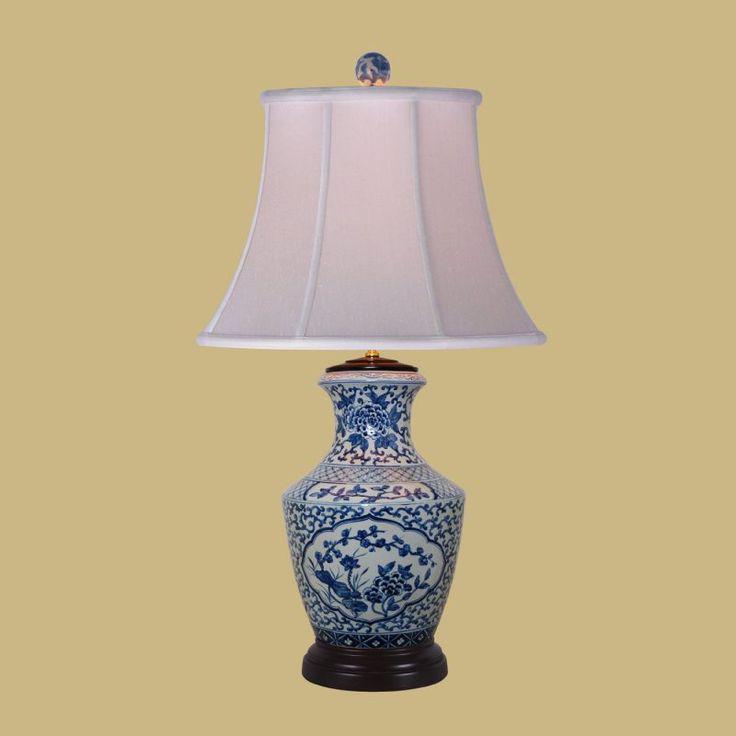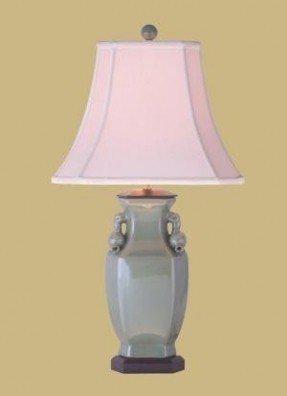The first image is the image on the left, the second image is the image on the right. Considering the images on both sides, is "At least one of the lamps shown features a shiny brass base." valid? Answer yes or no. No. The first image is the image on the left, the second image is the image on the right. Given the left and right images, does the statement "All ceramic objects are jade green, and at least one has a crackle finish, and at least one flares out at the top." hold true? Answer yes or no. No. 